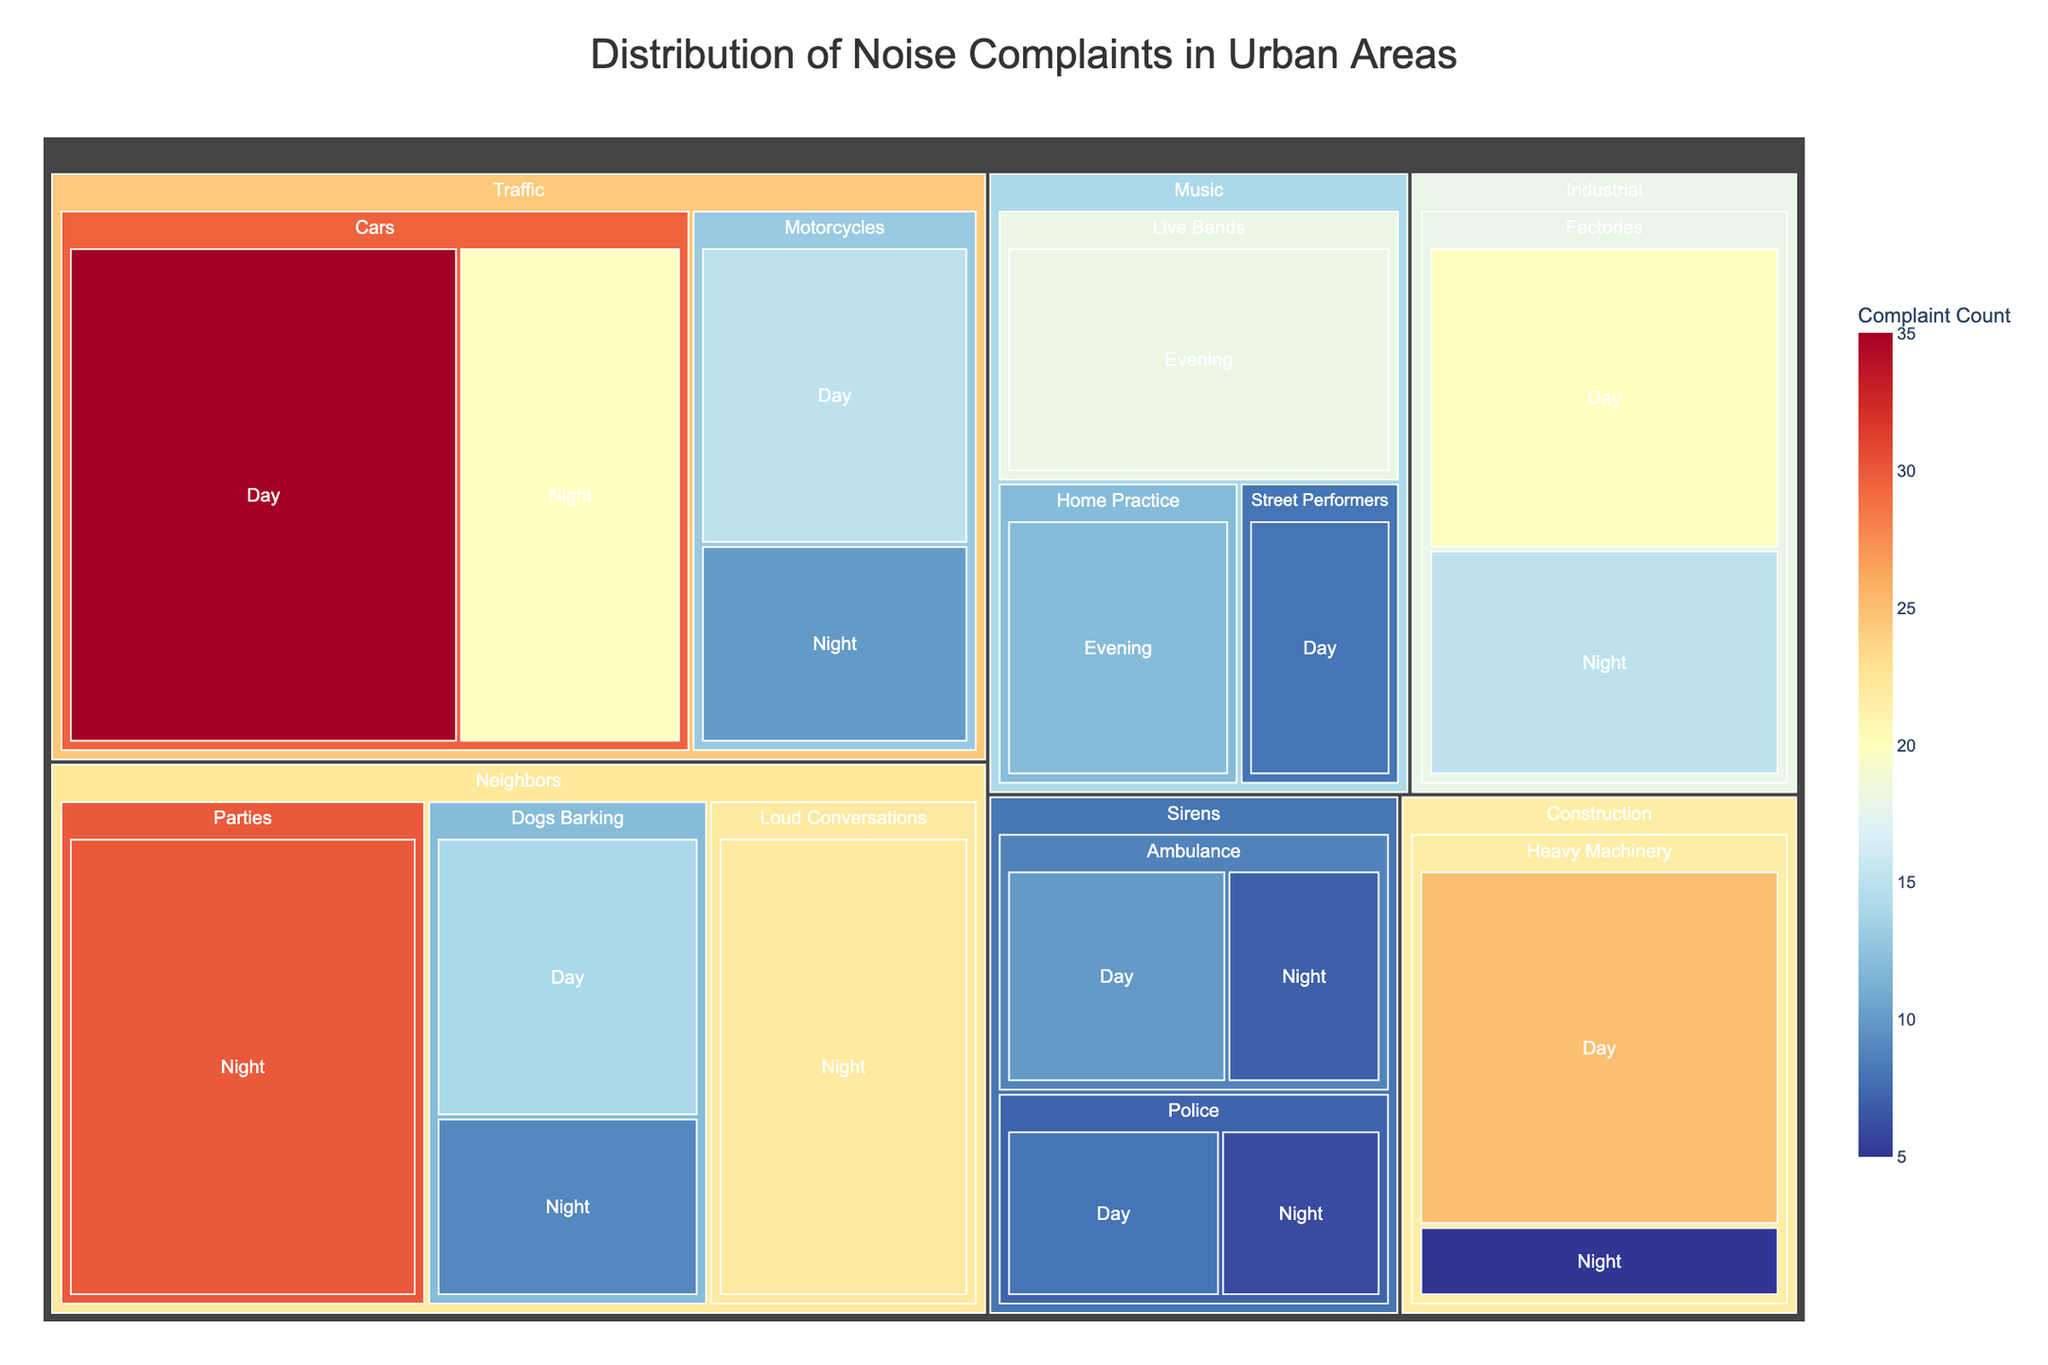What is the title of the figure? The title is usually prominently displayed at the top of the figure. In this case, it states the distribution of noise complaints.
Answer: Distribution of Noise Complaints in Urban Areas Which noise source has the highest complaint count at night? Locate the night time segments in the treemap and identify the one with the largest section. The 'Neighbors' category has several large segments at night.
Answer: Neighbors Which subcategory in 'Traffic' has more complaints during the day: Cars or Motorcycles? Within the 'Traffic' category, compare the segments for Cars and Motorcycles during the day. The Cars segment is larger.
Answer: Cars What is the total number of noise complaints from 'Music' sources in the evening? Identify and sum the values of the 'Music' subcategories that occur in the evening. The Values are 18 (Live Bands) + 12 (Home Practice) = 30.
Answer: 30 How many noise complaints are there from 'Sirens' during the night? Locate the 'Sirens' category and sum the values for night-time segments. The Values are 7 (Ambulance) + 6 (Police) = 13.
Answer: 13 Compare the number of noise complaints from 'Dogs Barking' during the day and night. Which is higher? Within the 'Neighbors' category, compare the day and night segments for 'Dogs Barking'. The day segment is larger.
Answer: Day What is the smallest segment in the 'Construction' category? Look at the segments within the 'Construction' category and identify the one with the smallest value. The smallest is Heavy Machinery at night.
Answer: Heavy Machinery at night Which category has a segment with exactly 15 complaints? Review the segments for each category to find one with a value of 15. In 'Traffic', the Motorcycles at night segment has exactly 15 complaints.
Answer: Traffic, Motorcycles, Day How many categories are represented in this treemap? Count the number of top-level segments. Each segment represents a different category. The categories are Traffic, Construction, Music, Neighbors, Industrial, Sirens.
Answer: 6 What is the difference in the number of complaints between 'Heavy Machinery' during the day and night? Subtract the smaller value (night) from the larger value (day). The Values are 25 (day) - 5 (night) = 20.
Answer: 20 